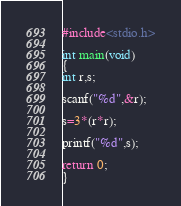<code> <loc_0><loc_0><loc_500><loc_500><_C_>#include<stdio.h>

int main(void)
{
int r,s;

scanf("%d",&r);

s=3*(r*r);

printf("%d",s);

return 0;
}
</code> 